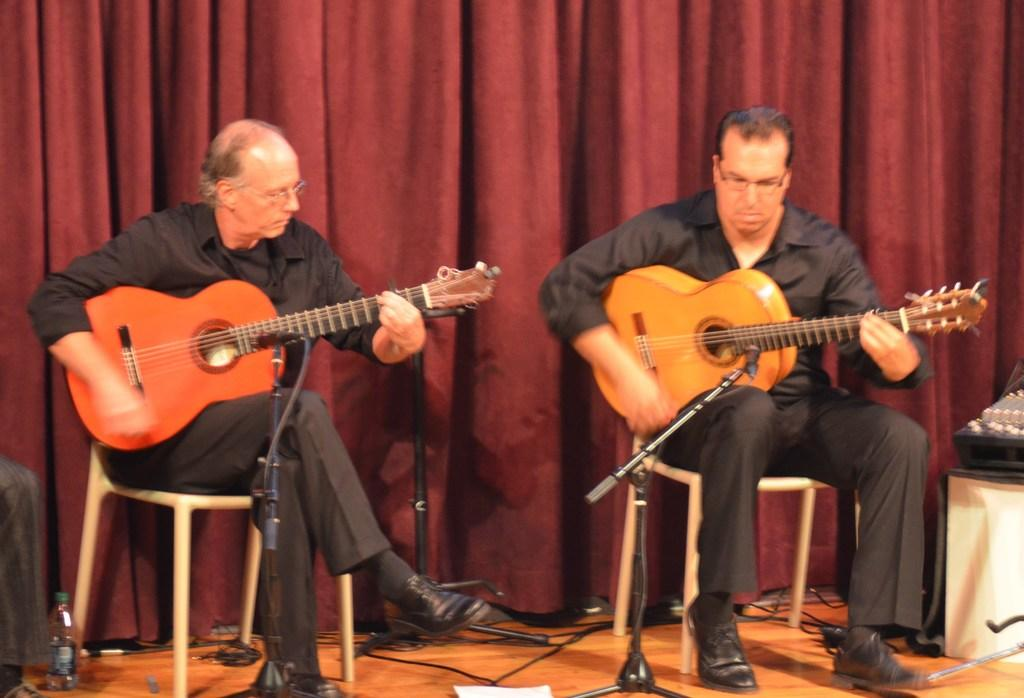How many people are in the image? There are two persons in the image. What are the persons doing in the image? The persons are sitting on chairs and playing guitars. What can be seen in the background of the image? There are curtains in the background of the image. What type of spy equipment can be seen in the image? There is no spy equipment present in the image; it features two persons playing guitars. Can you tell me how many toads are sitting on the chairs with the persons? There are no toads present in the image; it only features two persons playing guitars. 